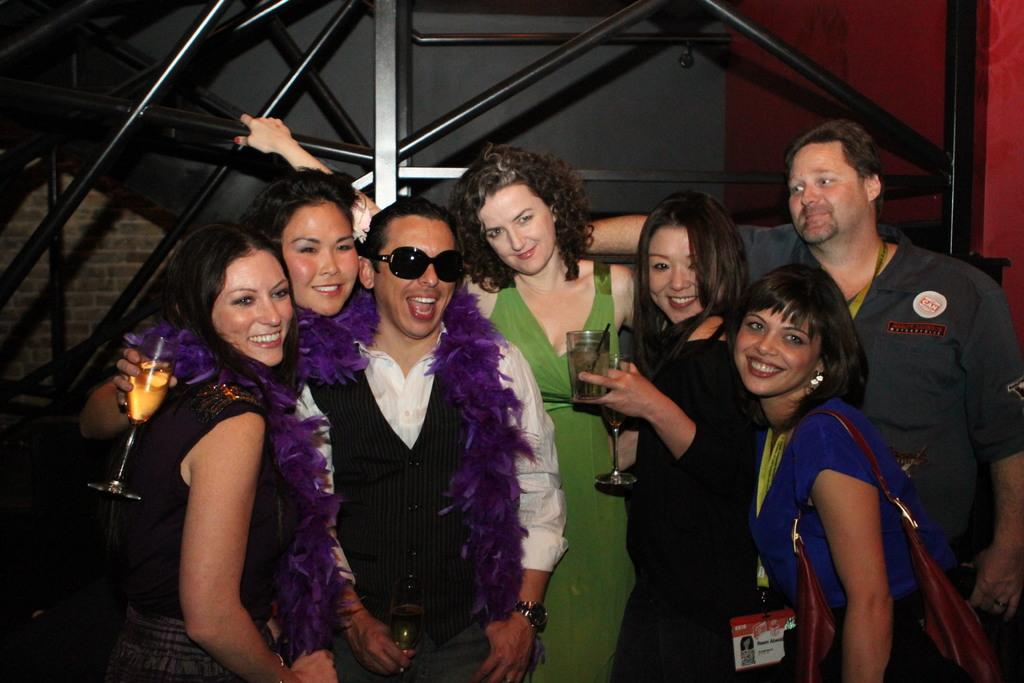Who or what can be seen in the image? There are people in the image. What objects are present in the image besides the people? There are rods and a wall in the image. What are two people doing in the image? Two people are holding bottles. What accessory is the woman wearing in the image? The woman is wearing a handbag. What direction is the zebra facing in the image? There is no zebra present in the image. What color is the paint on the wall in the image? The provided facts do not mention the color of the paint on the wall, so we cannot answer this question definitively. 